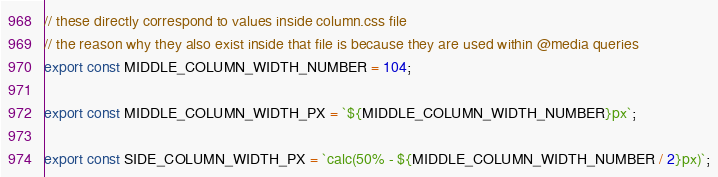Convert code to text. <code><loc_0><loc_0><loc_500><loc_500><_TypeScript_>// these directly correspond to values inside column.css file
// the reason why they also exist inside that file is because they are used within @media queries
export const MIDDLE_COLUMN_WIDTH_NUMBER = 104;

export const MIDDLE_COLUMN_WIDTH_PX = `${MIDDLE_COLUMN_WIDTH_NUMBER}px`;

export const SIDE_COLUMN_WIDTH_PX = `calc(50% - ${MIDDLE_COLUMN_WIDTH_NUMBER / 2}px)`;
</code> 